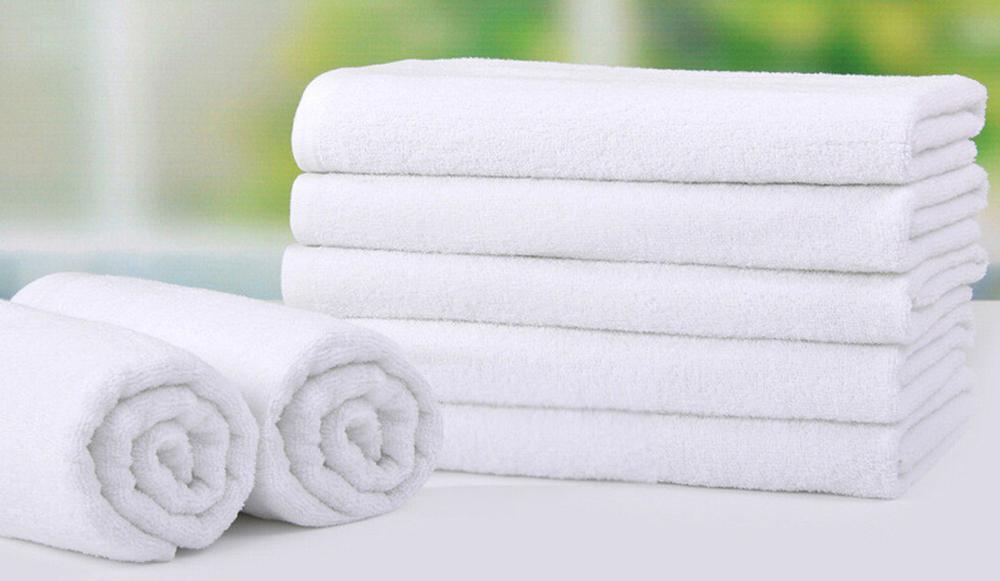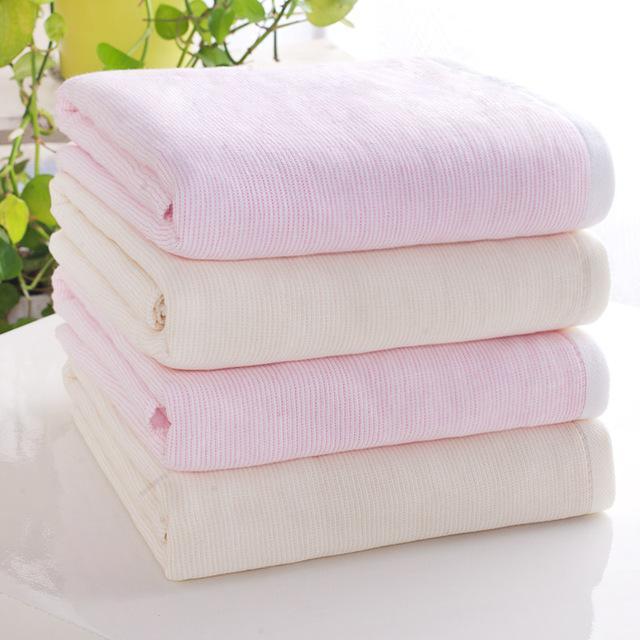The first image is the image on the left, the second image is the image on the right. For the images displayed, is the sentence "the right image has 4 neatly folded and stacked bath towels" factually correct? Answer yes or no. Yes. The first image is the image on the left, the second image is the image on the right. Assess this claim about the two images: "In one of the images, there are towels that are not folded or rolled.". Correct or not? Answer yes or no. No. 